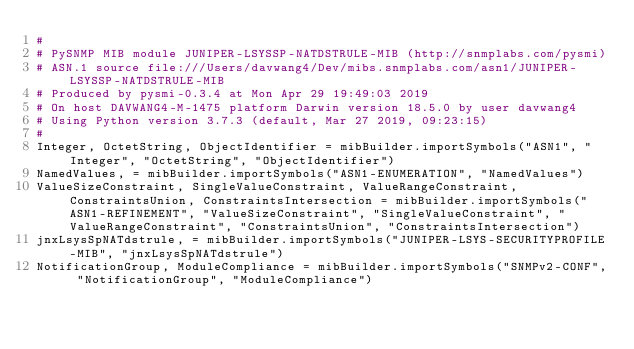<code> <loc_0><loc_0><loc_500><loc_500><_Python_>#
# PySNMP MIB module JUNIPER-LSYSSP-NATDSTRULE-MIB (http://snmplabs.com/pysmi)
# ASN.1 source file:///Users/davwang4/Dev/mibs.snmplabs.com/asn1/JUNIPER-LSYSSP-NATDSTRULE-MIB
# Produced by pysmi-0.3.4 at Mon Apr 29 19:49:03 2019
# On host DAVWANG4-M-1475 platform Darwin version 18.5.0 by user davwang4
# Using Python version 3.7.3 (default, Mar 27 2019, 09:23:15) 
#
Integer, OctetString, ObjectIdentifier = mibBuilder.importSymbols("ASN1", "Integer", "OctetString", "ObjectIdentifier")
NamedValues, = mibBuilder.importSymbols("ASN1-ENUMERATION", "NamedValues")
ValueSizeConstraint, SingleValueConstraint, ValueRangeConstraint, ConstraintsUnion, ConstraintsIntersection = mibBuilder.importSymbols("ASN1-REFINEMENT", "ValueSizeConstraint", "SingleValueConstraint", "ValueRangeConstraint", "ConstraintsUnion", "ConstraintsIntersection")
jnxLsysSpNATdstrule, = mibBuilder.importSymbols("JUNIPER-LSYS-SECURITYPROFILE-MIB", "jnxLsysSpNATdstrule")
NotificationGroup, ModuleCompliance = mibBuilder.importSymbols("SNMPv2-CONF", "NotificationGroup", "ModuleCompliance")</code> 